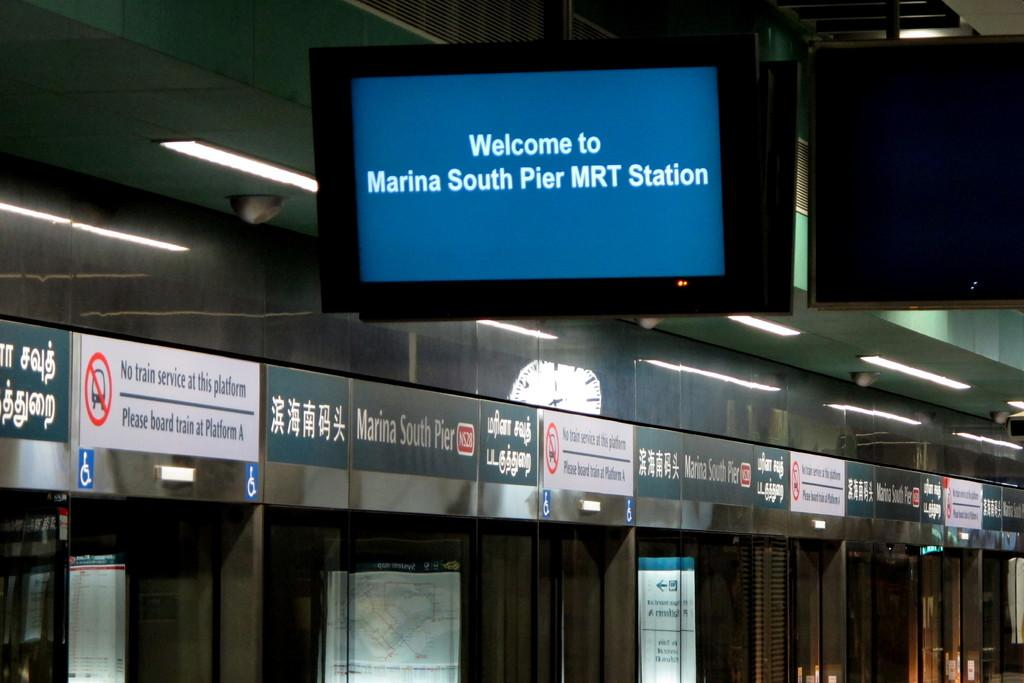<image>
Describe the image concisely. The tv screen welcomes travellers to Marina South Pier MRT Station. 